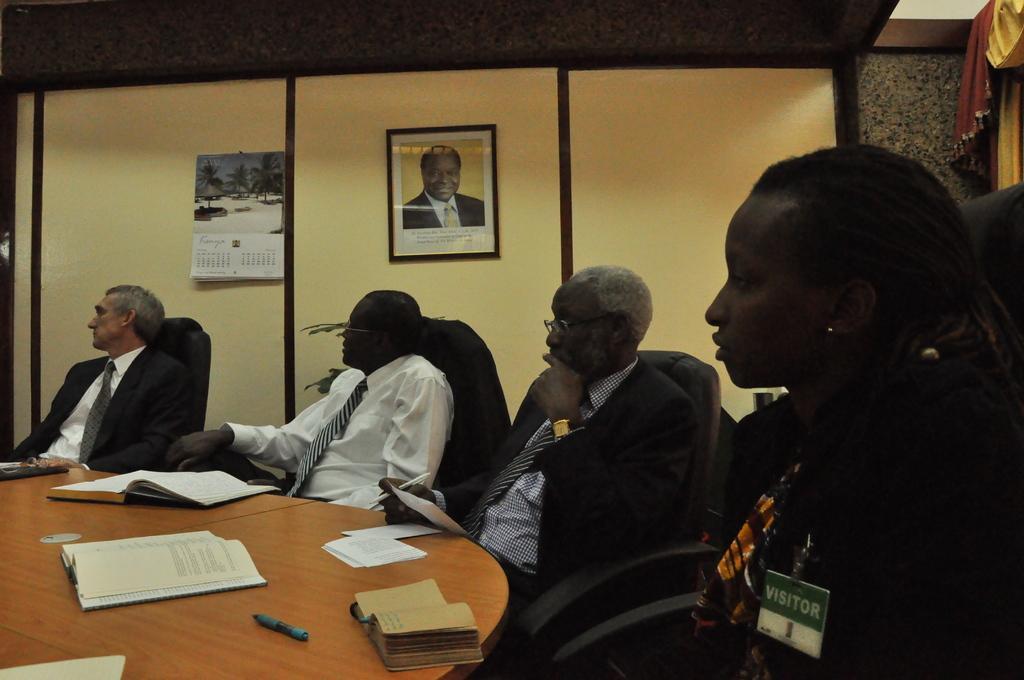Can you describe this image briefly? In the foreground of the picture there are people, chairs, books, table and pen. In the background there are frame and calendar. On the right there is a curtain. 